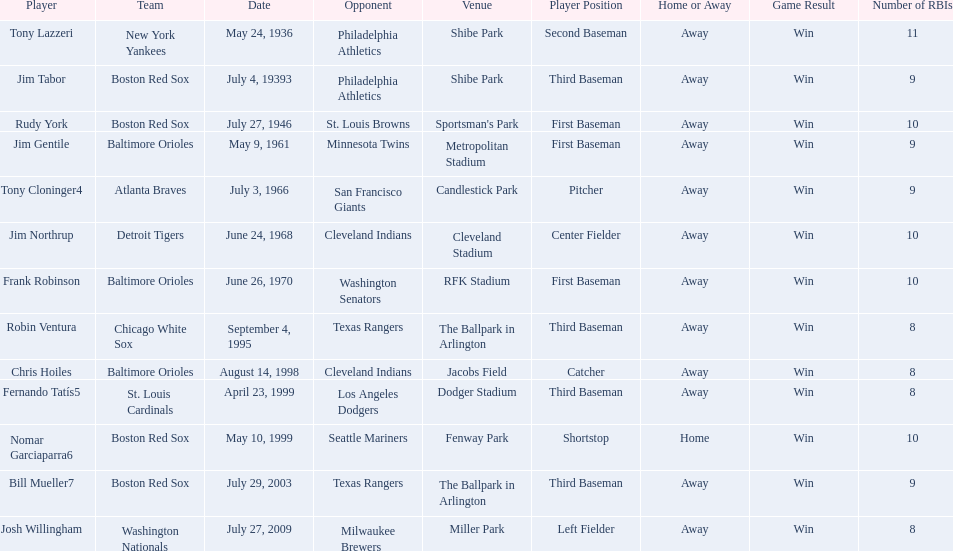What are the names of all the players? Tony Lazzeri, Jim Tabor, Rudy York, Jim Gentile, Tony Cloninger4, Jim Northrup, Frank Robinson, Robin Ventura, Chris Hoiles, Fernando Tatís5, Nomar Garciaparra6, Bill Mueller7, Josh Willingham. What are the names of all the teams holding home run records? New York Yankees, Boston Red Sox, Baltimore Orioles, Atlanta Braves, Detroit Tigers, Chicago White Sox, St. Louis Cardinals, Washington Nationals. Which player played for the new york yankees? Tony Lazzeri. 